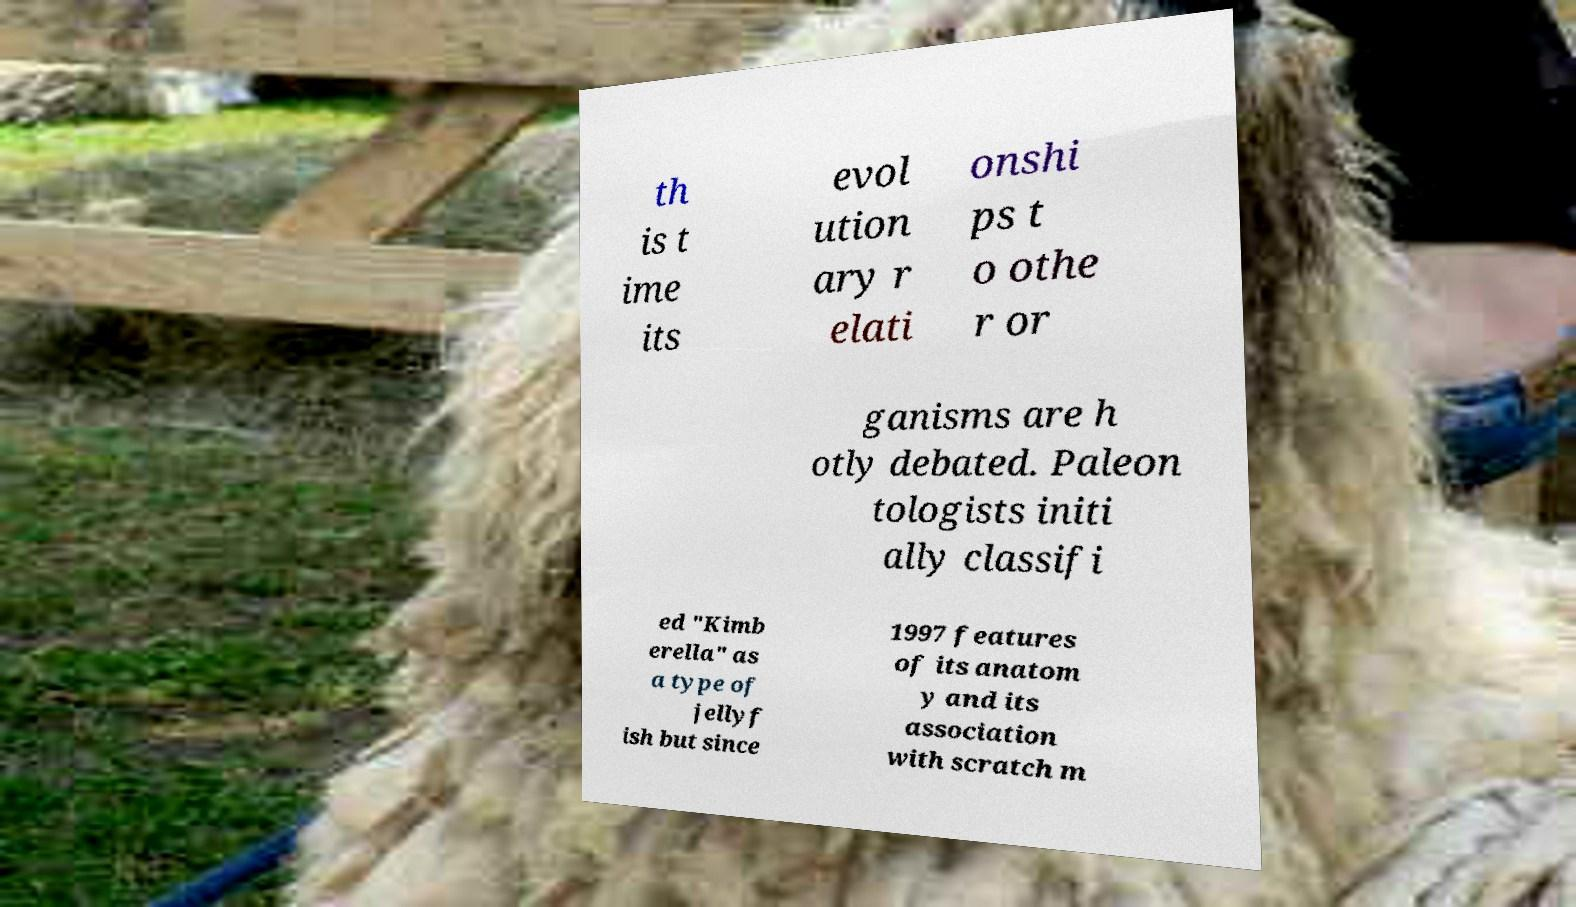Please identify and transcribe the text found in this image. th is t ime its evol ution ary r elati onshi ps t o othe r or ganisms are h otly debated. Paleon tologists initi ally classifi ed "Kimb erella" as a type of jellyf ish but since 1997 features of its anatom y and its association with scratch m 